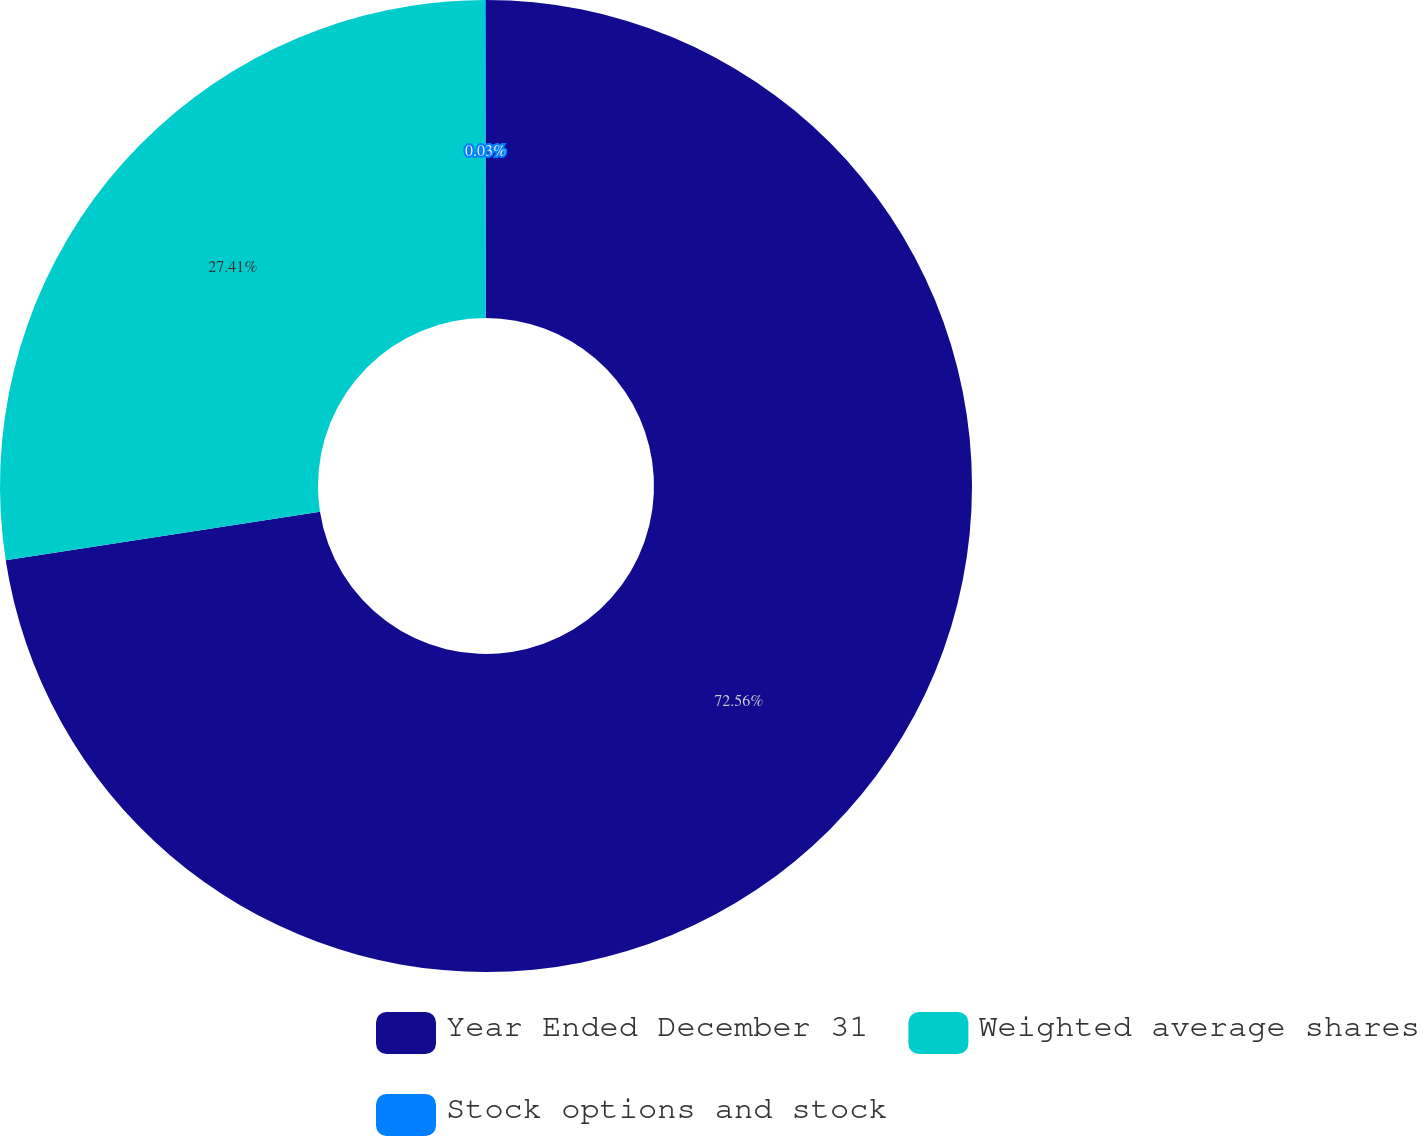<chart> <loc_0><loc_0><loc_500><loc_500><pie_chart><fcel>Year Ended December 31<fcel>Weighted average shares<fcel>Stock options and stock<nl><fcel>72.56%<fcel>27.41%<fcel>0.03%<nl></chart> 